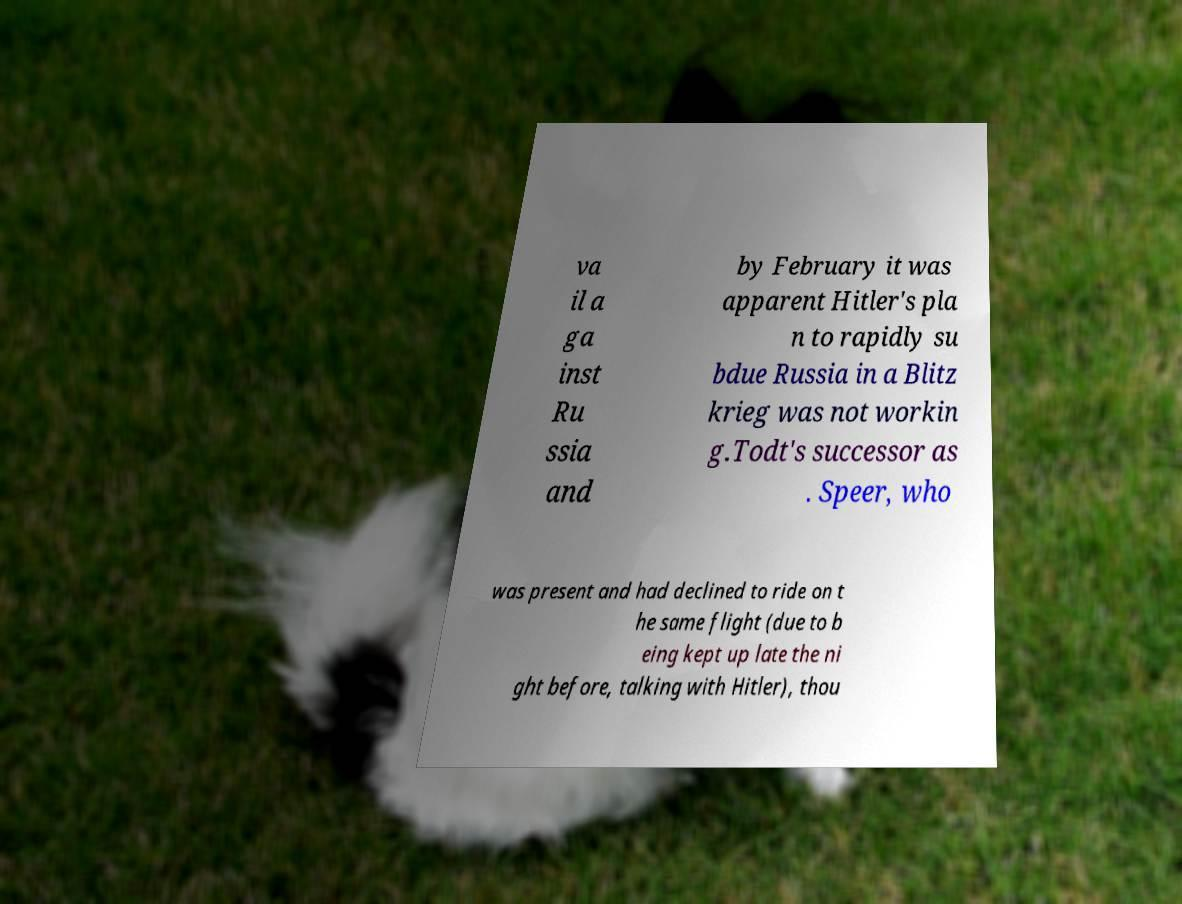I need the written content from this picture converted into text. Can you do that? va il a ga inst Ru ssia and by February it was apparent Hitler's pla n to rapidly su bdue Russia in a Blitz krieg was not workin g.Todt's successor as . Speer, who was present and had declined to ride on t he same flight (due to b eing kept up late the ni ght before, talking with Hitler), thou 